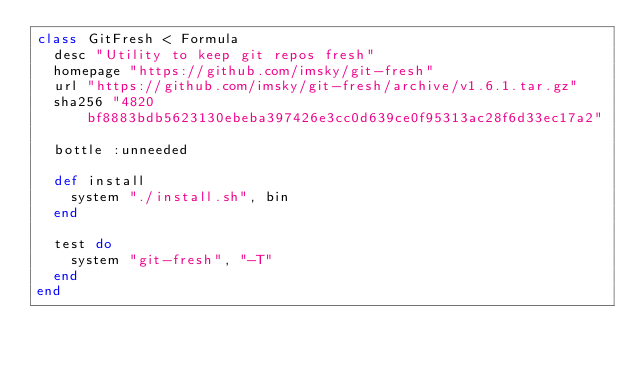<code> <loc_0><loc_0><loc_500><loc_500><_Ruby_>class GitFresh < Formula
  desc "Utility to keep git repos fresh"
  homepage "https://github.com/imsky/git-fresh"
  url "https://github.com/imsky/git-fresh/archive/v1.6.1.tar.gz"
  sha256 "4820bf8883bdb5623130ebeba397426e3cc0d639ce0f95313ac28f6d33ec17a2"

  bottle :unneeded

  def install
    system "./install.sh", bin
  end

  test do
    system "git-fresh", "-T"
  end
end
</code> 